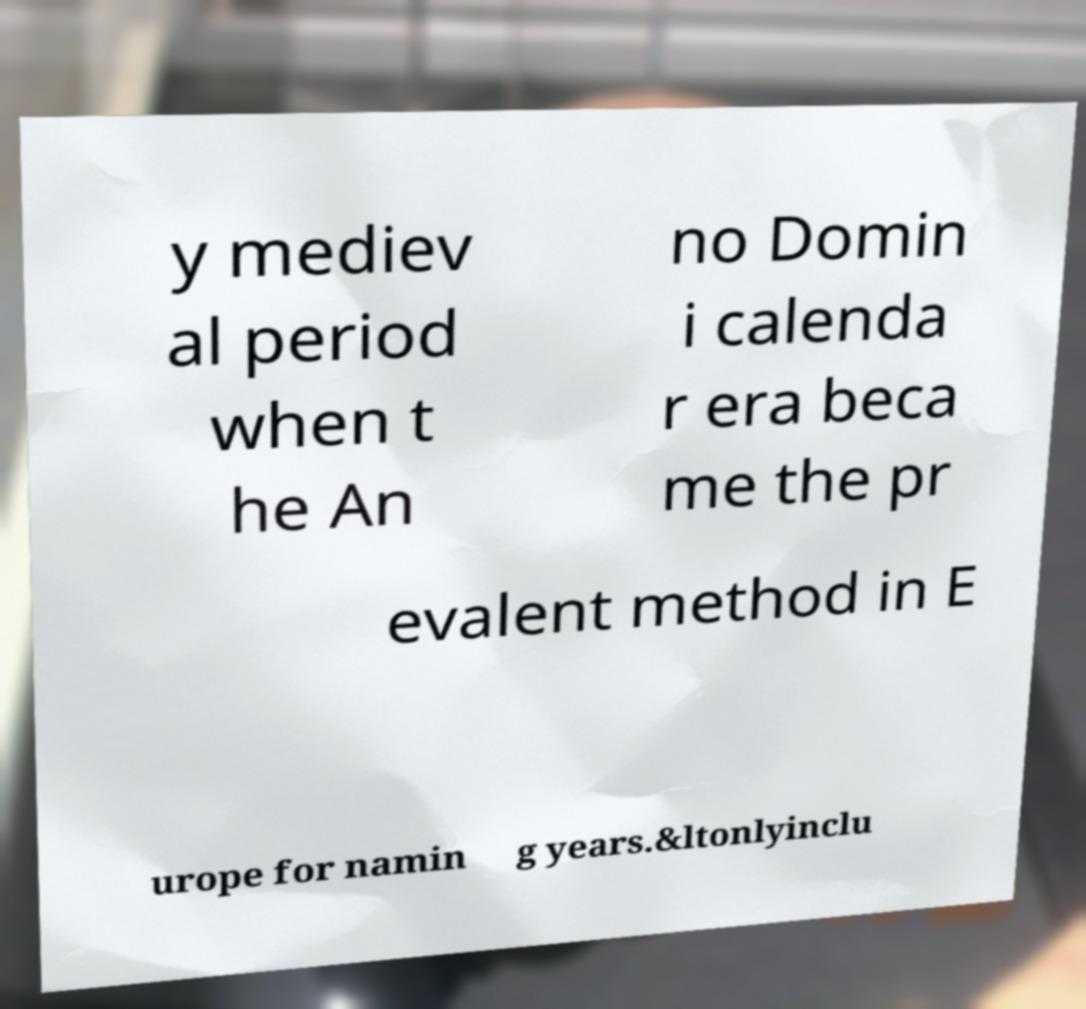For documentation purposes, I need the text within this image transcribed. Could you provide that? y mediev al period when t he An no Domin i calenda r era beca me the pr evalent method in E urope for namin g years.&ltonlyinclu 